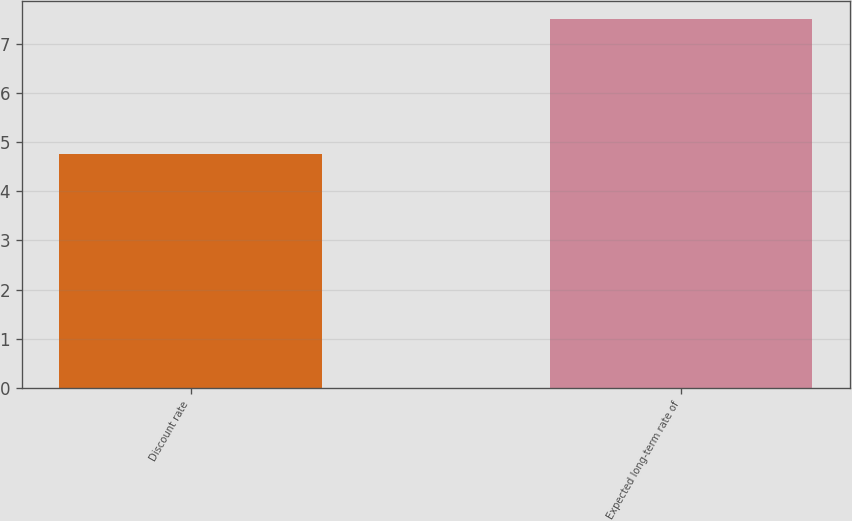Convert chart to OTSL. <chart><loc_0><loc_0><loc_500><loc_500><bar_chart><fcel>Discount rate<fcel>Expected long-term rate of<nl><fcel>4.75<fcel>7.5<nl></chart> 